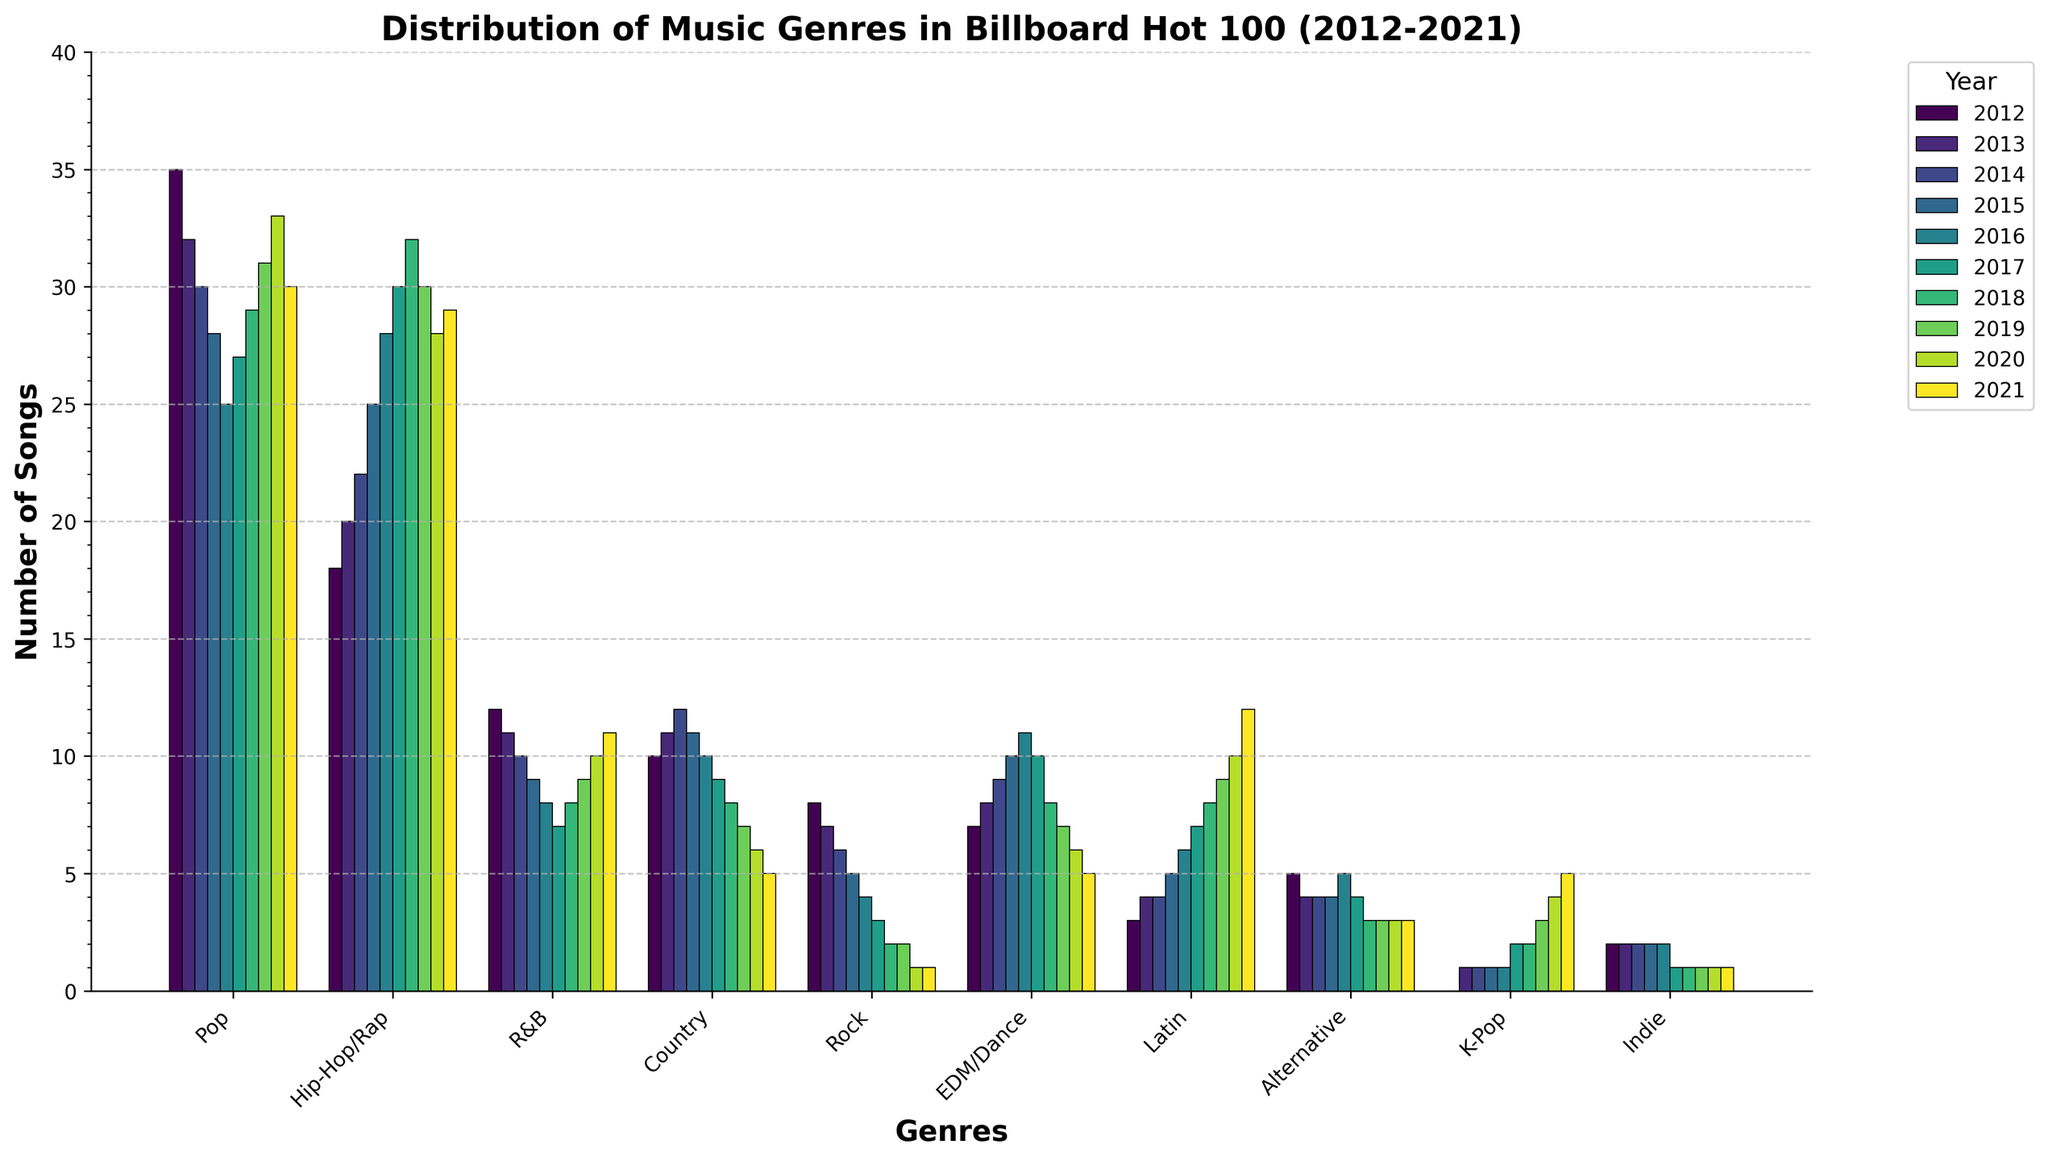Which genre showed the greatest increase in number of songs from 2012 to 2021? To find the genre with the greatest increase, subtract the number of songs in 2012 from the number of songs in 2021 for each genre. The genre with the highest positive difference is the one that increased the most. Hip-Hop/Rap increased from 18 to 29 songs, thus showing the greatest increase.
Answer: Hip-Hop/Rap Which genre had the most consistent number of songs throughout the decade? To identify the most consistent genre, look for the least variation in the number of songs across the years. Indie has consistently 1 or 2 songs each year, showing the least variation.
Answer: Indie How did the popularity of Rock change over the decade? To determine the change, observe the number of Rock songs from 2012 to 2021. Rock moved from 8 in 2012 to 1 in 2021, indicating a decreasing trend.
Answer: Decreasing Compare the popularity of Pop and Hip-Hop/Rap in 2021? Which one had more songs? To compare, look at the number of songs for both genres in 2021. Pop had 30 songs, while Hip-Hop/Rap had 29 songs in 2021.
Answer: Pop In which year did Latin music surpass both EDM/Dance and Alternative music in popularity? Compare the number of Latin songs to EDM/Dance and Alternative songs each year. In 2020, Latin (10 songs) surpassed both EDM/Dance (6 songs) and Alternative (3 songs).
Answer: 2020 What's the average number of Pop songs in the first five years compared to the last five years? Calculate the average for 2012-2016 and 2017-2021. For the first five years: (35+32+30+28+25) / 5 = 30. For the last five years: (27+29+31+33+30) / 5 = 30.
Answer: 30 for both periods Which three genres had the highest number of songs in 2018? Look at the data for 2018 and find the top three genres. Pop (29 songs), Hip-Hop/Rap (32 songs), and EDM/Dance (8 songs) were the top three.
Answer: Pop, Hip-Hop/Rap, EDM/Dance How did K-Pop's presence change from its first appearance to 2021? K-Pop appeared in 2013 with 1 song and grew to 5 songs by 2021, indicating an increasing trend.
Answer: Increasing In which year did Pop music reach its lowest point? Inspect the number of Pop songs each year and identify the year with the lowest count. Pop music had its lowest point in 2016 with 25 songs.
Answer: 2016 What was the overall trend for Country music over the decade? Observe the number of Country songs from 2012 to 2021. Country moved from 10 songs in 2012 to 5 songs in 2021, showing a declining trend.
Answer: Declining 